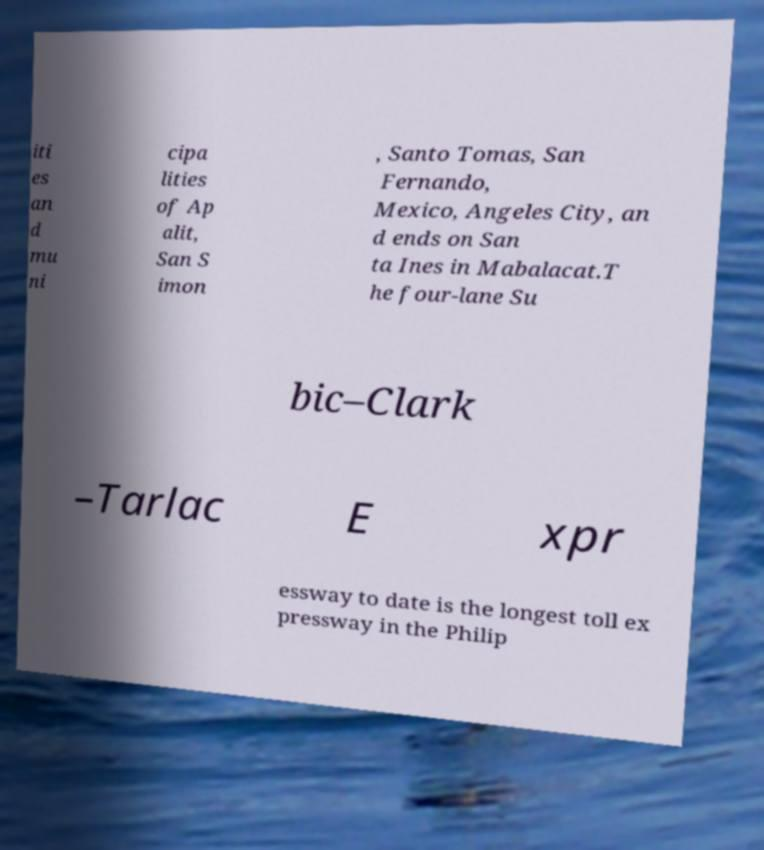Please read and relay the text visible in this image. What does it say? iti es an d mu ni cipa lities of Ap alit, San S imon , Santo Tomas, San Fernando, Mexico, Angeles City, an d ends on San ta Ines in Mabalacat.T he four-lane Su bic–Clark –Tarlac E xpr essway to date is the longest toll ex pressway in the Philip 